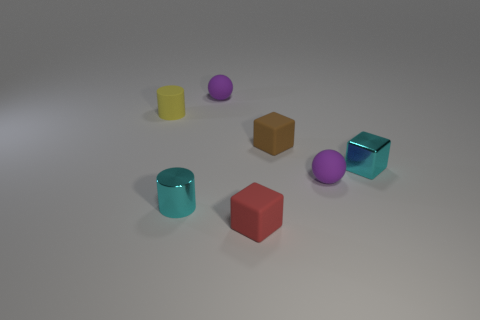How many other things are there of the same size as the brown thing?
Ensure brevity in your answer.  6. There is a shiny thing that is behind the small cyan shiny cylinder; what is its shape?
Give a very brief answer. Cube. Are the small red block and the ball behind the small cyan block made of the same material?
Your response must be concise. Yes. Is there a purple rubber thing?
Offer a terse response. Yes. There is a small brown block on the right side of the yellow matte thing that is left of the tiny red object; is there a small shiny cylinder that is on the right side of it?
Keep it short and to the point. No. How many small objects are either cyan shiny blocks or purple rubber things?
Offer a very short reply. 3. What is the color of the shiny cylinder that is the same size as the brown rubber block?
Offer a terse response. Cyan. How many small purple matte objects are in front of the metallic block?
Offer a terse response. 1. Is there a tiny cyan cube made of the same material as the brown object?
Keep it short and to the point. No. There is a object that is the same color as the shiny cylinder; what is its shape?
Your answer should be compact. Cube. 